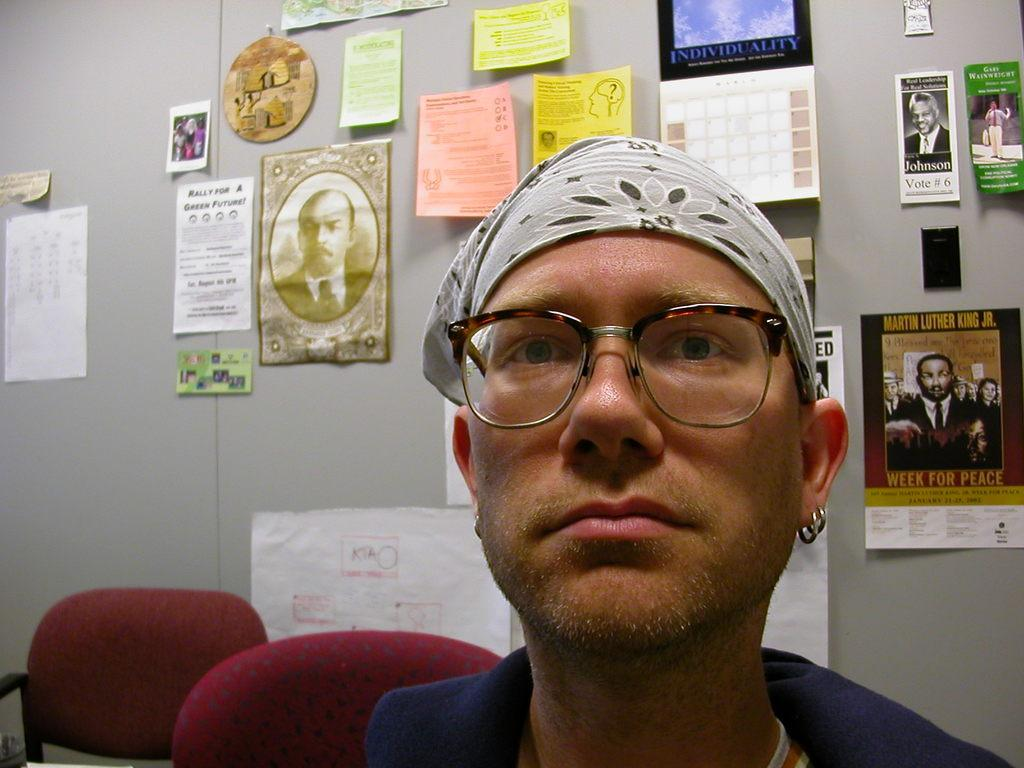Who is present in the image? There is a man in the image. What accessory is the man wearing? The man is wearing spectacles. What can be seen on the wall in the background? There are posters on the wall in the background. What type of furniture is visible in the image? There are chairs visible in the image. What type of coal is being used to fuel the horn in the image? There is no coal or horn present in the image. What activities might be associated with the summer season in the image? The provided facts do not mention any season or activities related to summer in the image. 